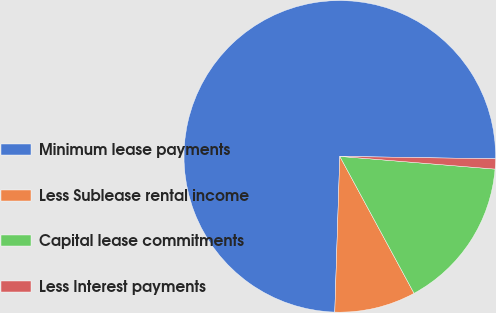Convert chart to OTSL. <chart><loc_0><loc_0><loc_500><loc_500><pie_chart><fcel>Minimum lease payments<fcel>Less Sublease rental income<fcel>Capital lease commitments<fcel>Less Interest payments<nl><fcel>74.74%<fcel>8.42%<fcel>15.79%<fcel>1.05%<nl></chart> 